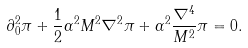Convert formula to latex. <formula><loc_0><loc_0><loc_500><loc_500>\partial _ { 0 } ^ { 2 } \pi + \frac { 1 } { 2 } \alpha ^ { 2 } M ^ { 2 } \nabla ^ { 2 } \pi + \alpha ^ { 2 } \frac { \nabla ^ { 4 } } { M ^ { 2 } } \pi = 0 .</formula> 